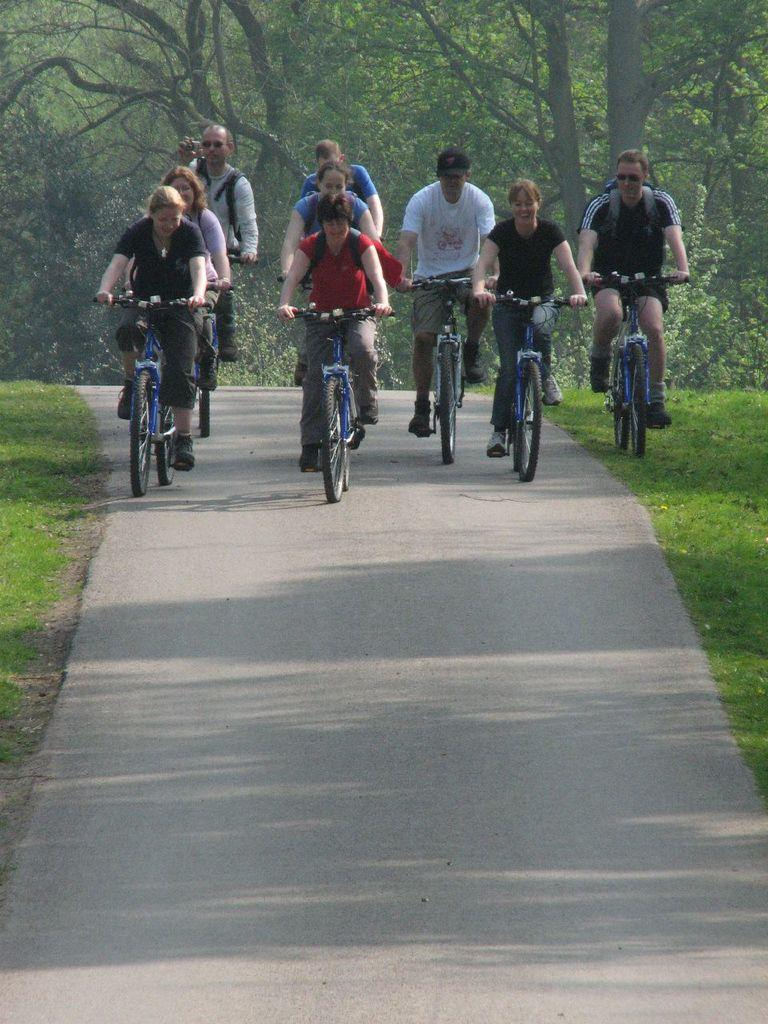What can be seen in the background of the image? There are trees in the background of the image. What are the persons in the image doing? The persons in the image are riding bicycles on the road. What type of vegetation is present in the image? There is fresh green grass in the image. What type of watch is the person wearing while riding the bicycle in the image? There is no watch visible on the person riding the bicycle in the image. What type of drug is being used by the person riding the bicycle in the image? There is no indication of any drug use in the image; the persons are simply riding bicycles on the road. 